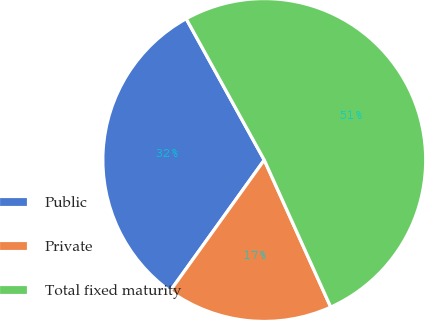Convert chart. <chart><loc_0><loc_0><loc_500><loc_500><pie_chart><fcel>Public<fcel>Private<fcel>Total fixed maturity<nl><fcel>32.05%<fcel>16.67%<fcel>51.28%<nl></chart> 